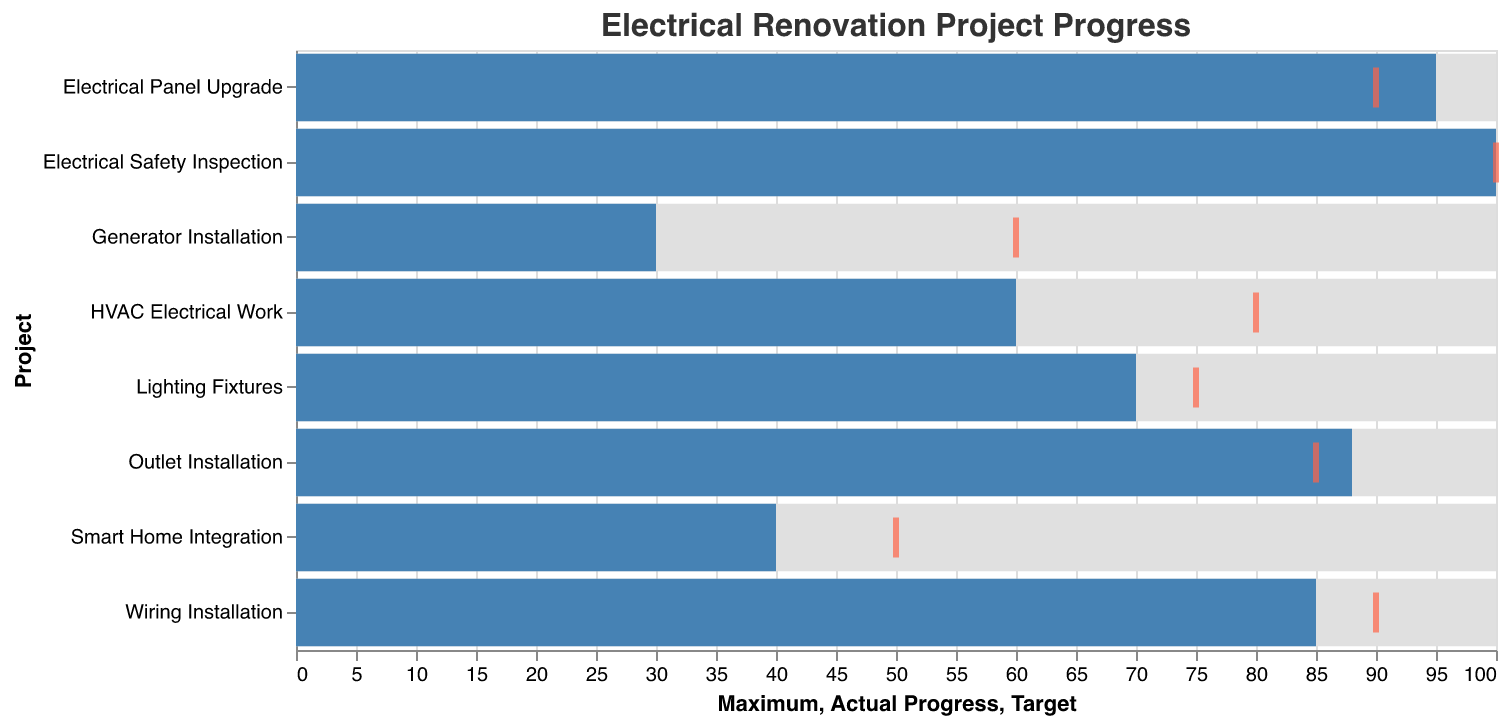What is the title of the chart? The title can be found at the top of the chart and typically indicates the main idea or the primary data being visualized.
Answer: Electrical Renovation Project Progress Which project has the highest actual progress? Look at the bar with the darkest color and the highest value on the progress bar, which lies closest to the maximal value of 100.
Answer: Electrical Safety Inspection What is the target progress for the HVAC Electrical Work? Locate the tick mark colored in a distinct shade (typically red) for the HVAC Electrical Work bar, and this represents the target progress.
Answer: 80 Which projects exceeded their target progress? Compare the actual progress bars to the target tick marks for each project and identify which bars exceed their respective tick marks.
Answer: Electrical Panel Upgrade, Outlet Installation How many projects have a target progress of 90? Count the number of tick marks positioned at the value of 90 across different projects.
Answer: 2 What is the difference between actual progress and target progress for Smart Home Integration? Subtract the target progress value from the actual progress value for Smart Home Integration.
Answer: -10 Which project is furthest behind its target? Identify the project with the largest negative difference when subtracting the target progress from the actual progress.
Answer: Generator Installation What is the average actual progress across all projects? Add up all the actual progress values and divide by the number of projects to find the average.
Answer: 70.75 Which project is closest to its maximum progress? Find the project where the actual progress value is the closest to 100, the maximum progress.
Answer: Electrical Safety Inspection Are there any projects where the actual progress is exactly equal to the target progress? Check if any of the actual progress bars reach exactly to the target tick marks.
Answer: Electrical Safety Inspection 